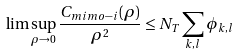Convert formula to latex. <formula><loc_0><loc_0><loc_500><loc_500>\lim \sup _ { \rho \to 0 } \frac { C _ { m i m o - i } ( \rho ) } { \rho ^ { 2 } } \leq N _ { T } \sum _ { k , l } \phi _ { k , l }</formula> 